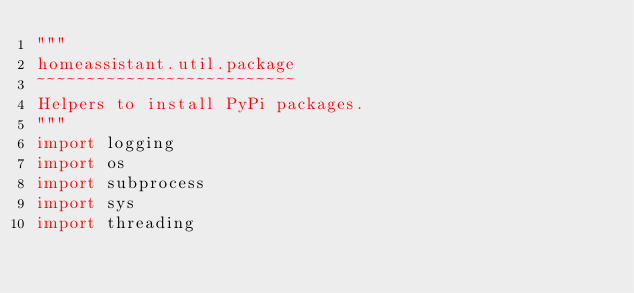<code> <loc_0><loc_0><loc_500><loc_500><_Python_>"""
homeassistant.util.package
~~~~~~~~~~~~~~~~~~~~~~~~~~
Helpers to install PyPi packages.
"""
import logging
import os
import subprocess
import sys
import threading</code> 